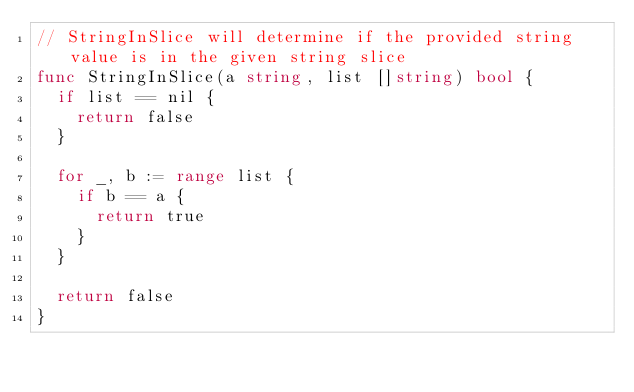<code> <loc_0><loc_0><loc_500><loc_500><_Go_>// StringInSlice will determine if the provided string value is in the given string slice
func StringInSlice(a string, list []string) bool {
	if list == nil {
		return false
	}

	for _, b := range list {
		if b == a {
			return true
		}
	}

	return false
}
</code> 